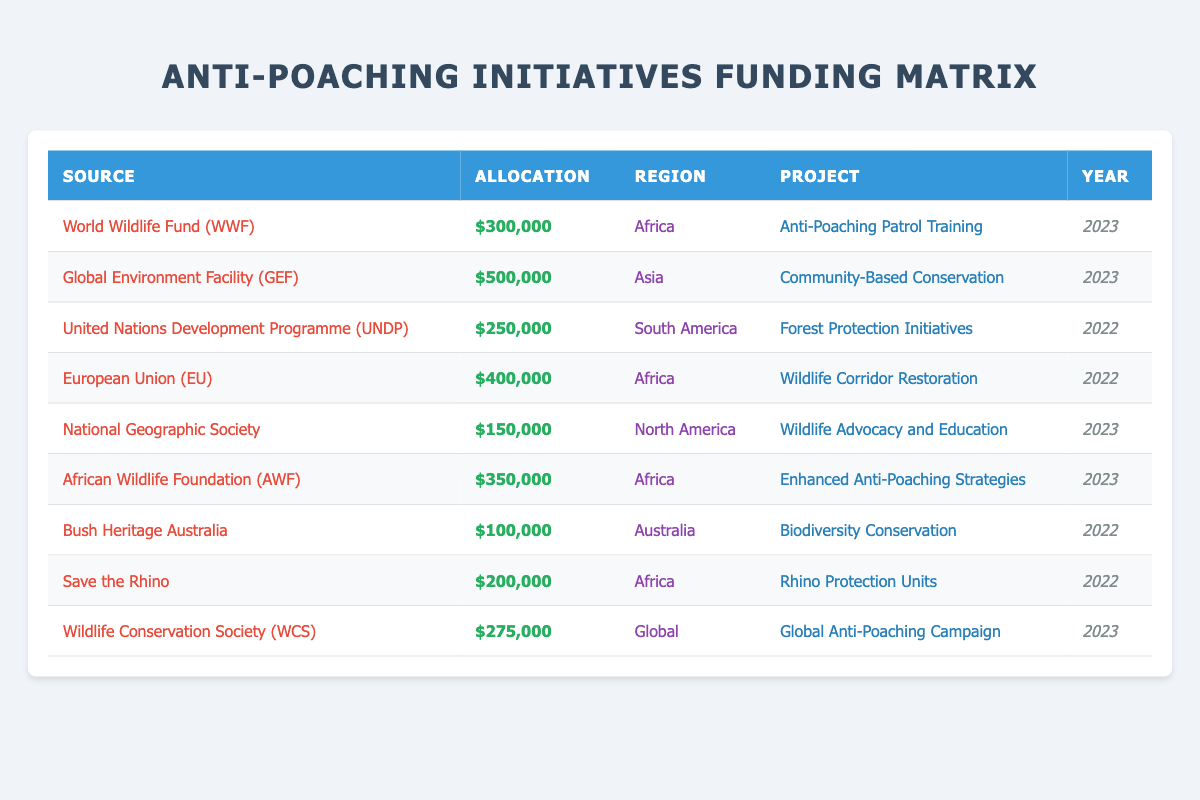What projects received funding from the World Wildlife Fund (WWF)? The table lists several funding sources and their corresponding projects. To find the project funded by WWF, look for the row with "World Wildlife Fund (WWF)" in the Source column. The project listed for this source is "Anti-Poaching Patrol Training."
Answer: Anti-Poaching Patrol Training How much total funding was allocated to anti-poaching initiatives in Africa for the year 2023? First, filter for rows where the Region is "Africa" and the Year is "2023." The relevant allocations are $300,000 from WWF, $350,000 from AWF, and $200,000 from Save the Rhino. Adding these amounts gives $300,000 + $350,000 + $200,000 = $850,000.
Answer: $850,000 Did the Global Environment Facility (GEF) fund any projects in Africa? Check the row for GEF, which is in the Source column. It shows that the region specified is "Asia," meaning GEF did not fund any projects in Africa.
Answer: No What is the average allocation of the projects listed in South America? The only project listed in South America is from the United Nations Development Programme (UNDP) with an allocation of $250,000. Since there is only one data point, the average allocation is the same as the allocation itself. Therefore, the average is $250,000/1 = $250,000.
Answer: $250,000 Which funding source had the highest allocation in 2022? Look at the rows for the year 2022 and identify the allocations: UNDP ($250,000), EU ($400,000), Bush Heritage Australia ($100,000), and Save the Rhino ($200,000). The highest allocation is from the European Union, which allocated $400,000.
Answer: European Union (EU) What is the total amount allocated to projects in Australia? The table shows one project in Australia funded by Bush Heritage Australia with an allocation of $100,000. Since there is only one entry, the total allocation is simply $100,000.
Answer: $100,000 How many different regions received funding for anti-poaching projects in 2023? Review the table for the year 2023 and check the Region column. The regions listed are Africa (2 projects), Asia (1 project), North America (1 project), and Global (1 project). In total, four different regions received funding in 2023.
Answer: Four Was there any project funded by National Geographic Society? Find the row for National Geographic Society in the Source column. The project listed is "Wildlife Advocacy and Education," confirming that there was indeed a funded project.
Answer: Yes Which project received the second highest total funding across all years? Identify all funding amounts in descending order. The highest allocation is $500,000 for GEF's Community-Based Conservation in Asia. The second highest allocation is $400,000 for the EU's Wildlife Corridor Restoration in Africa. Therefore the project with the second highest funding is EU's project.
Answer: Wildlife Corridor Restoration 